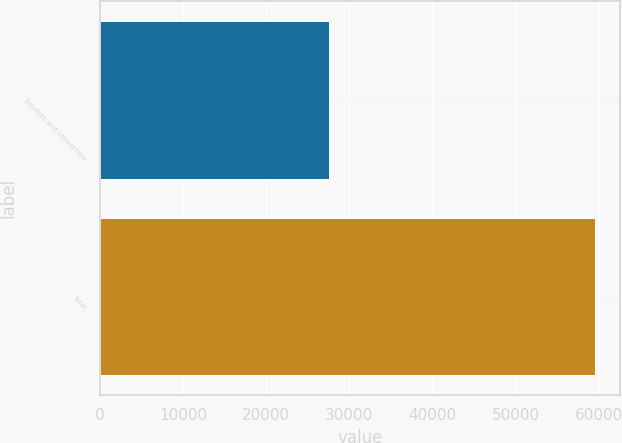<chart> <loc_0><loc_0><loc_500><loc_500><bar_chart><fcel>Equities and convertible<fcel>Total<nl><fcel>27587<fcel>59589<nl></chart> 